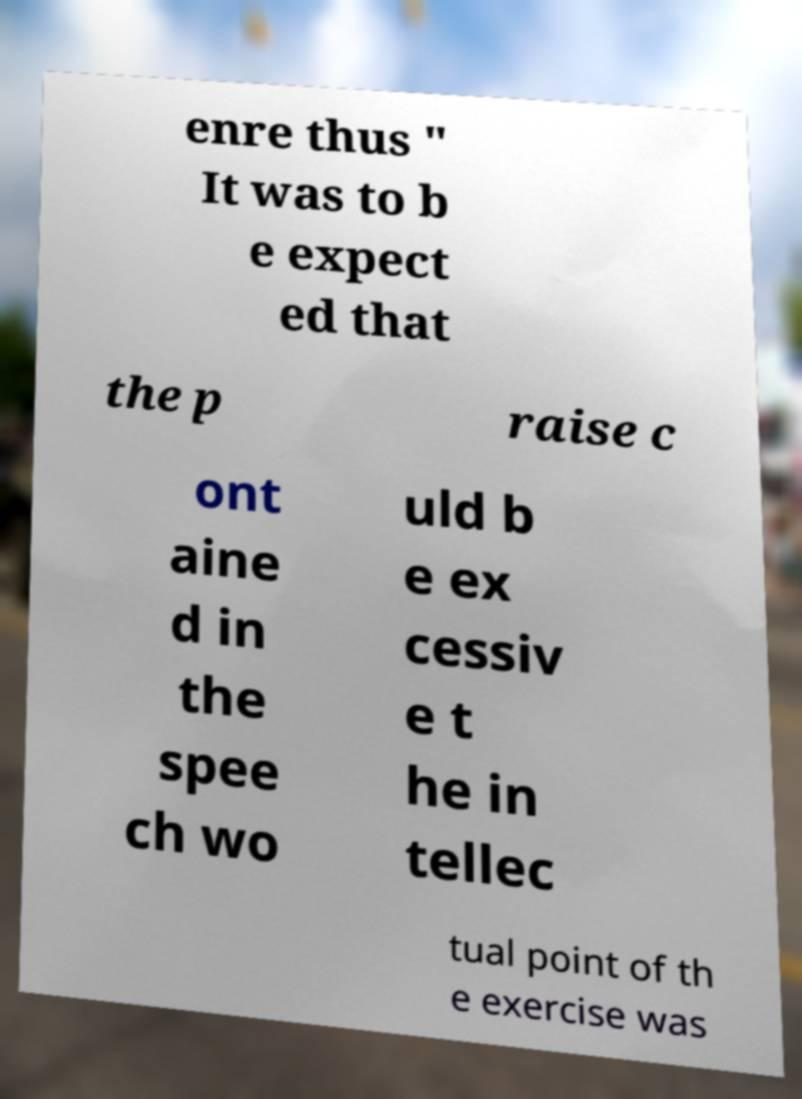There's text embedded in this image that I need extracted. Can you transcribe it verbatim? enre thus " It was to b e expect ed that the p raise c ont aine d in the spee ch wo uld b e ex cessiv e t he in tellec tual point of th e exercise was 